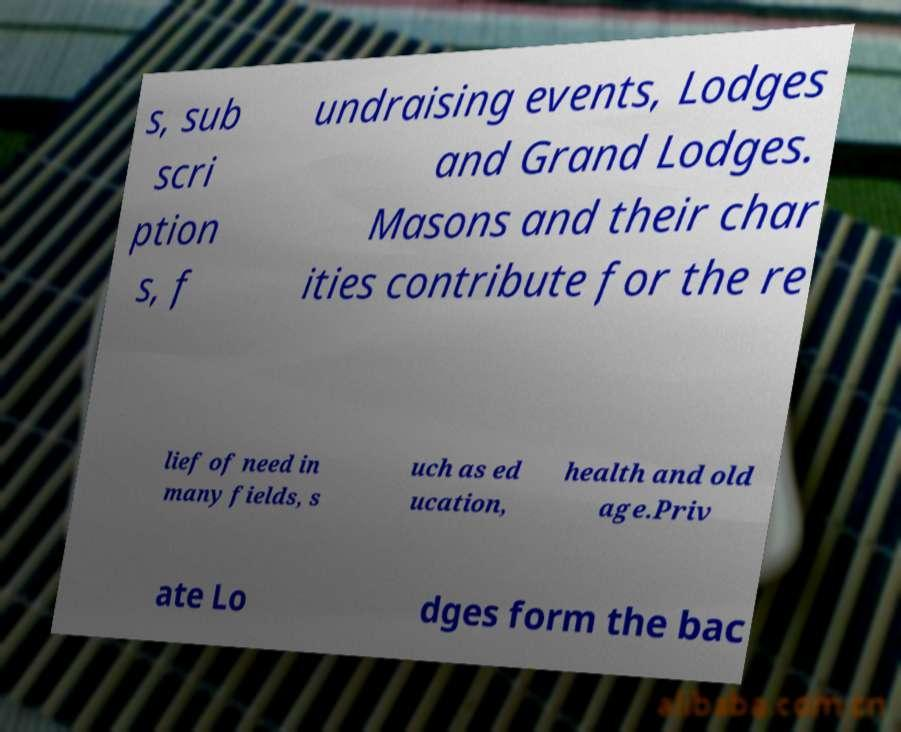Could you assist in decoding the text presented in this image and type it out clearly? s, sub scri ption s, f undraising events, Lodges and Grand Lodges. Masons and their char ities contribute for the re lief of need in many fields, s uch as ed ucation, health and old age.Priv ate Lo dges form the bac 